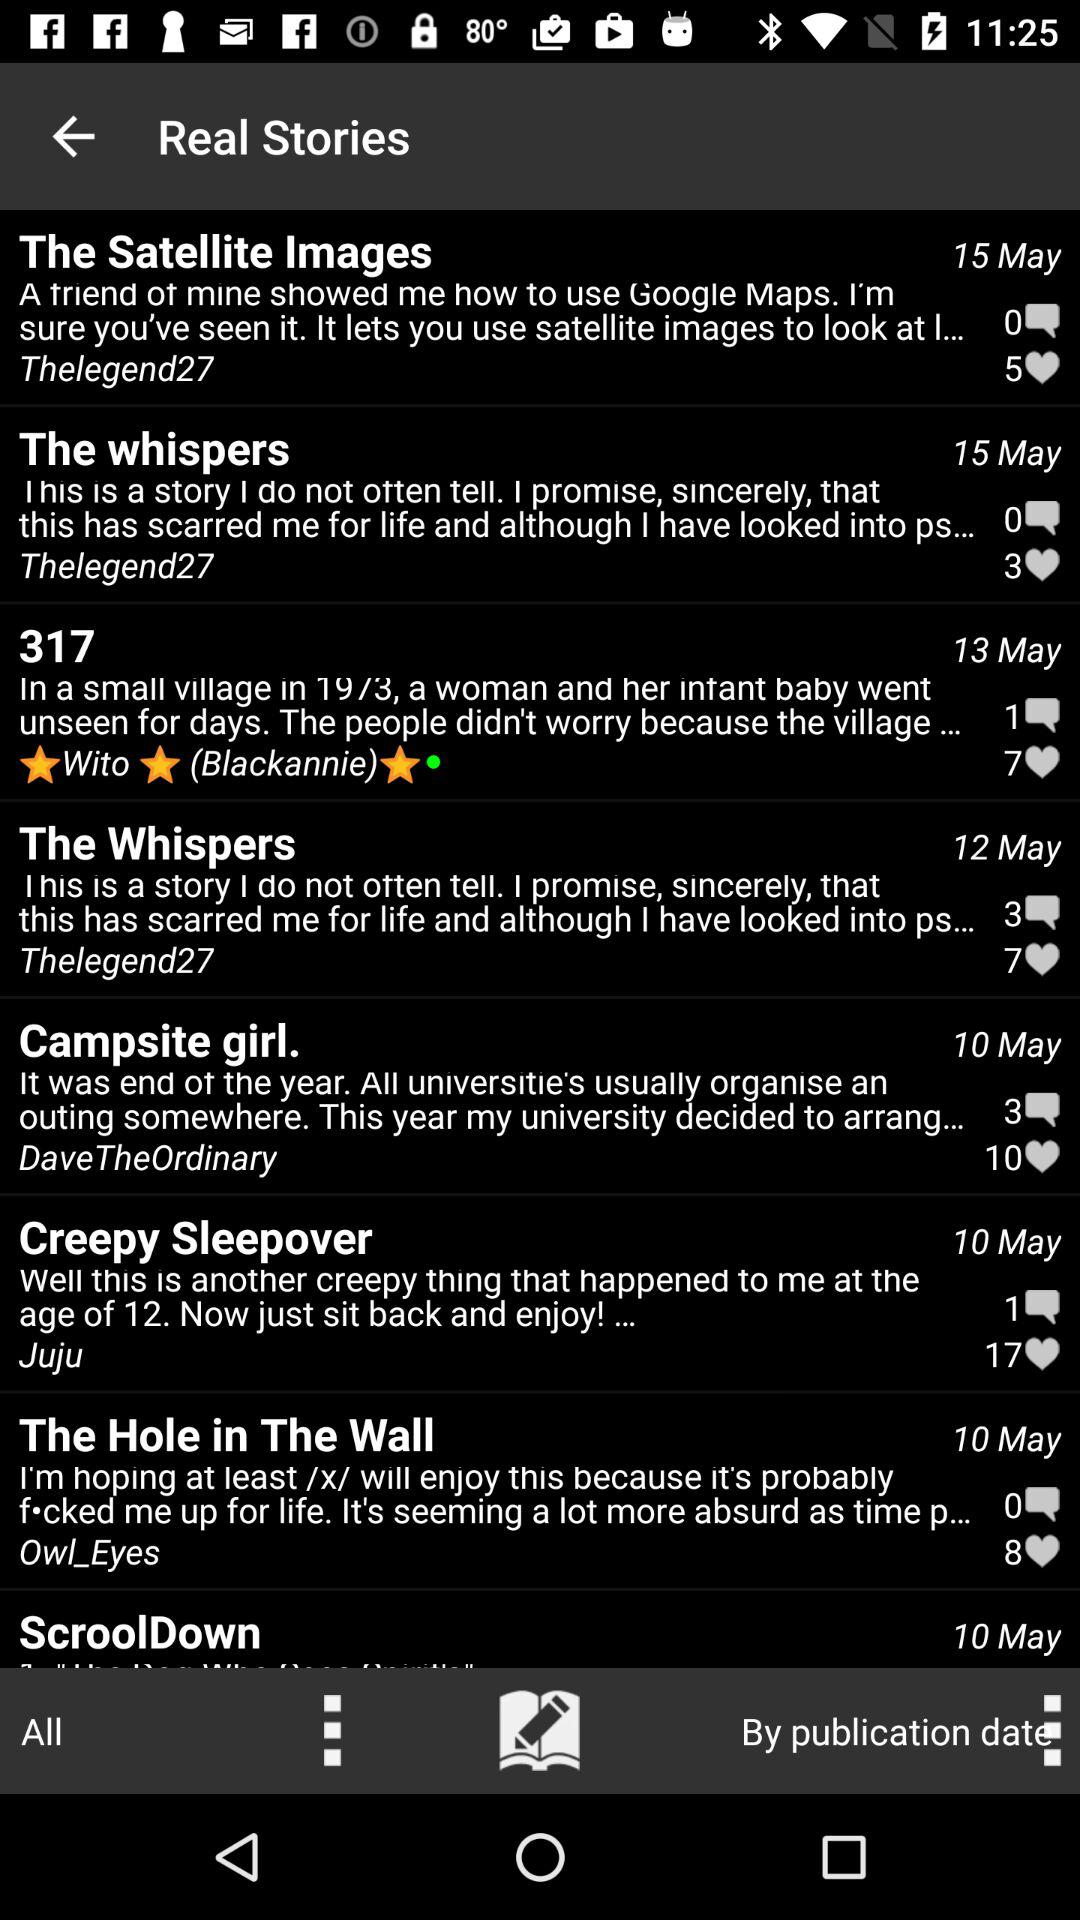What date is shown in the satellite images? The date is May 15. 